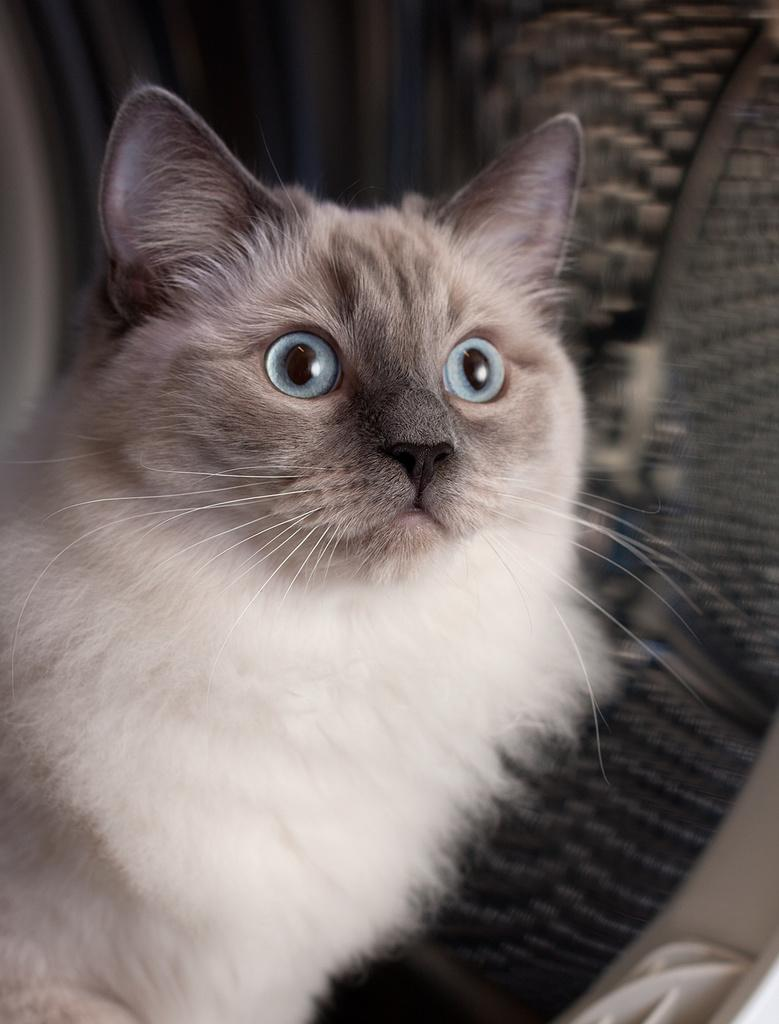What type of animal is present in the image? There is a cat in the image. Can you describe the color of the cat? The cat is white and brown in color. How many fathers are present in the image? There are no fathers present in the image; it features a cat. What type of building can be seen in the image? There is no building present in the image; it features a cat. 